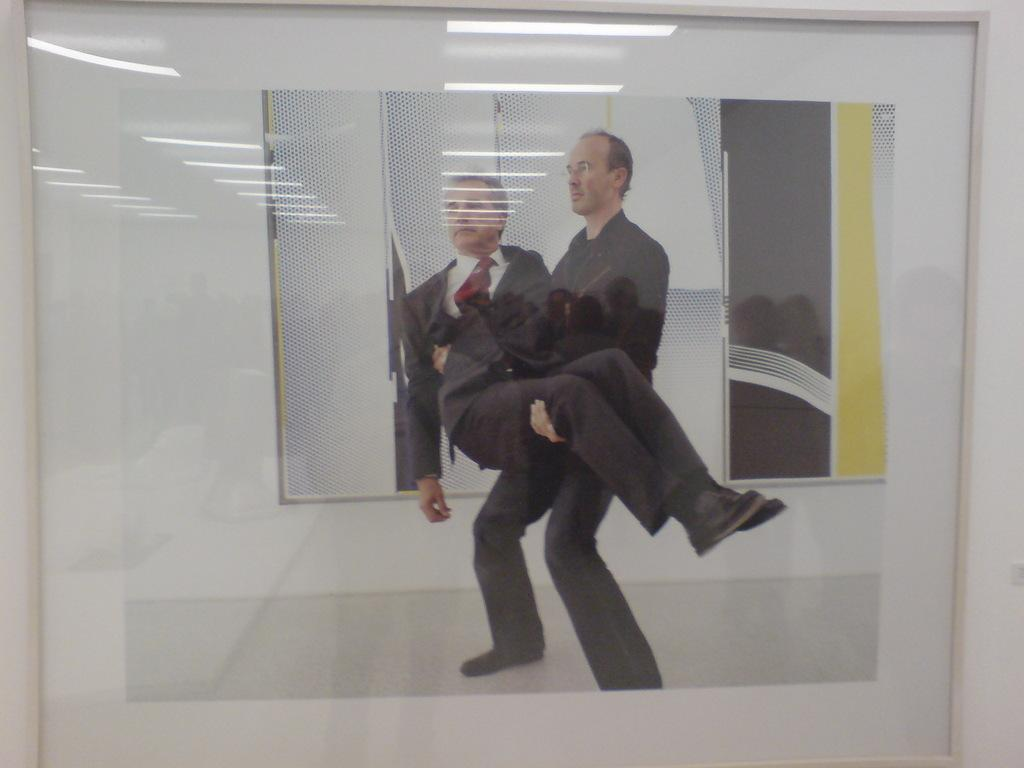What is happening between the two people in the image? There is a person holding another person in the image. What type of spark can be seen coming from the person's toothpaste in the image? There is no toothpaste or spark present in the image. What reason does the person holding another person have for doing so in the image? The reason for the person holding another person cannot be determined from the image alone. 